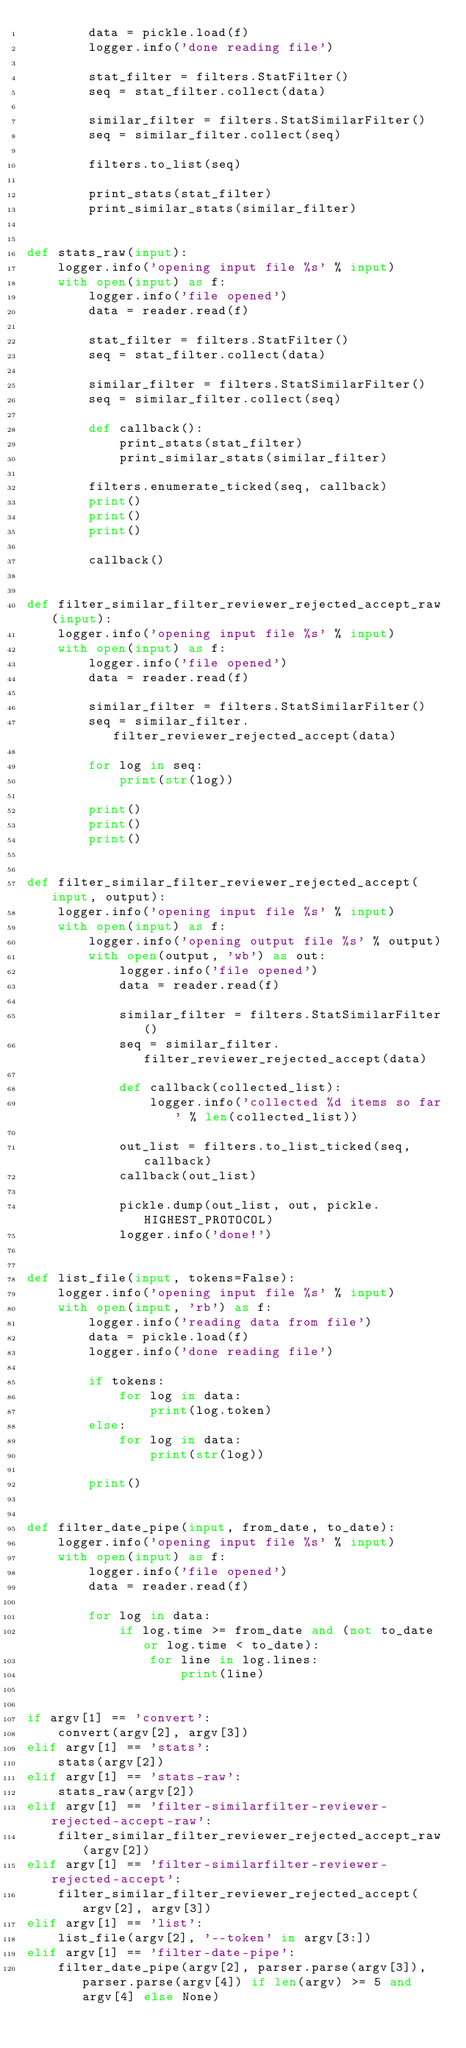Convert code to text. <code><loc_0><loc_0><loc_500><loc_500><_Python_>        data = pickle.load(f)
        logger.info('done reading file')

        stat_filter = filters.StatFilter()
        seq = stat_filter.collect(data)

        similar_filter = filters.StatSimilarFilter()
        seq = similar_filter.collect(seq)

        filters.to_list(seq)

        print_stats(stat_filter)
        print_similar_stats(similar_filter)


def stats_raw(input):
    logger.info('opening input file %s' % input)
    with open(input) as f:
        logger.info('file opened')
        data = reader.read(f)

        stat_filter = filters.StatFilter()
        seq = stat_filter.collect(data)

        similar_filter = filters.StatSimilarFilter()
        seq = similar_filter.collect(seq)

        def callback():
            print_stats(stat_filter)
            print_similar_stats(similar_filter)

        filters.enumerate_ticked(seq, callback)
        print()
        print()
        print()

        callback()


def filter_similar_filter_reviewer_rejected_accept_raw(input):
    logger.info('opening input file %s' % input)
    with open(input) as f:
        logger.info('file opened')
        data = reader.read(f)

        similar_filter = filters.StatSimilarFilter()
        seq = similar_filter.filter_reviewer_rejected_accept(data)

        for log in seq:
            print(str(log))

        print()
        print()
        print()


def filter_similar_filter_reviewer_rejected_accept(input, output):
    logger.info('opening input file %s' % input)
    with open(input) as f:
        logger.info('opening output file %s' % output)
        with open(output, 'wb') as out:
            logger.info('file opened')
            data = reader.read(f)

            similar_filter = filters.StatSimilarFilter()
            seq = similar_filter.filter_reviewer_rejected_accept(data)

            def callback(collected_list):
                logger.info('collected %d items so far' % len(collected_list))

            out_list = filters.to_list_ticked(seq, callback)
            callback(out_list)

            pickle.dump(out_list, out, pickle.HIGHEST_PROTOCOL)
            logger.info('done!')


def list_file(input, tokens=False):
    logger.info('opening input file %s' % input)
    with open(input, 'rb') as f:
        logger.info('reading data from file')
        data = pickle.load(f)
        logger.info('done reading file')

        if tokens:
            for log in data:
                print(log.token)
        else:
            for log in data:
                print(str(log))

        print()


def filter_date_pipe(input, from_date, to_date):
    logger.info('opening input file %s' % input)
    with open(input) as f:
        logger.info('file opened')
        data = reader.read(f)

        for log in data:
            if log.time >= from_date and (not to_date or log.time < to_date):
                for line in log.lines:
                    print(line)


if argv[1] == 'convert':
    convert(argv[2], argv[3])
elif argv[1] == 'stats':
    stats(argv[2])
elif argv[1] == 'stats-raw':
    stats_raw(argv[2])
elif argv[1] == 'filter-similarfilter-reviewer-rejected-accept-raw':
    filter_similar_filter_reviewer_rejected_accept_raw(argv[2])
elif argv[1] == 'filter-similarfilter-reviewer-rejected-accept':
    filter_similar_filter_reviewer_rejected_accept(argv[2], argv[3])
elif argv[1] == 'list':
    list_file(argv[2], '--token' in argv[3:])
elif argv[1] == 'filter-date-pipe':
    filter_date_pipe(argv[2], parser.parse(argv[3]), parser.parse(argv[4]) if len(argv) >= 5 and argv[4] else None)
</code> 